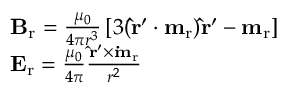Convert formula to latex. <formula><loc_0><loc_0><loc_500><loc_500>\begin{array} { r l } & { B _ { r } = \frac { \mu _ { 0 } } { 4 \pi r ^ { 3 } } \left [ 3 ( \hat { r } ^ { \prime } \cdot m _ { r } ) \hat { r } ^ { \prime } - m _ { r } \right ] } \\ & { E _ { r } = \frac { \mu _ { 0 } } { 4 \pi } \frac { \hat { r } ^ { \prime } \times \dot { m } _ { r } } { r ^ { 2 } } } \end{array}</formula> 